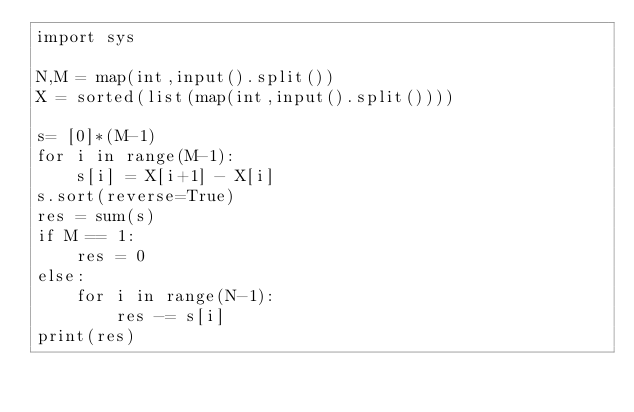Convert code to text. <code><loc_0><loc_0><loc_500><loc_500><_Python_>import sys

N,M = map(int,input().split())
X = sorted(list(map(int,input().split())))

s= [0]*(M-1)
for i in range(M-1):
    s[i] = X[i+1] - X[i]
s.sort(reverse=True)
res = sum(s)
if M == 1:
    res = 0
else:
    for i in range(N-1):
        res -= s[i]
print(res)</code> 